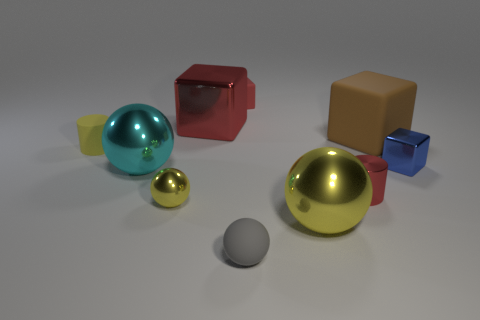Subtract all cubes. How many objects are left? 6 Add 3 large red metal cubes. How many large red metal cubes exist? 4 Subtract 0 blue balls. How many objects are left? 10 Subtract all yellow metal cylinders. Subtract all tiny shiny things. How many objects are left? 7 Add 1 gray matte balls. How many gray matte balls are left? 2 